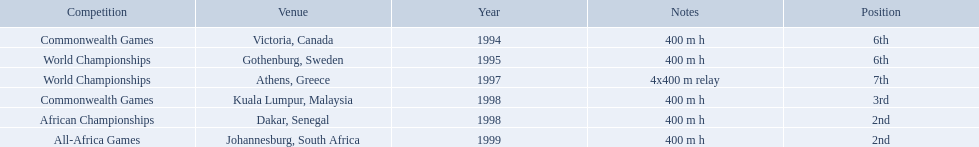Write the full table. {'header': ['Competition', 'Venue', 'Year', 'Notes', 'Position'], 'rows': [['Commonwealth Games', 'Victoria, Canada', '1994', '400 m h', '6th'], ['World Championships', 'Gothenburg, Sweden', '1995', '400 m h', '6th'], ['World Championships', 'Athens, Greece', '1997', '4x400 m relay', '7th'], ['Commonwealth Games', 'Kuala Lumpur, Malaysia', '1998', '400 m h', '3rd'], ['African Championships', 'Dakar, Senegal', '1998', '400 m h', '2nd'], ['All-Africa Games', 'Johannesburg, South Africa', '1999', '400 m h', '2nd']]} What races did ken harden run? 400 m h, 400 m h, 4x400 m relay, 400 m h, 400 m h, 400 m h. Which race did ken harden run in 1997? 4x400 m relay. 